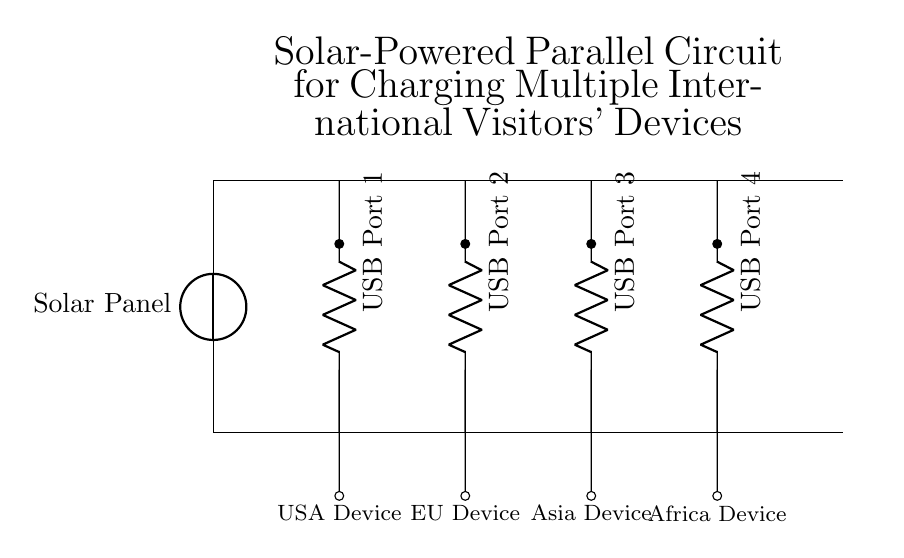What components are used in this circuit? The circuit diagram shows a solar panel and four USB ports. Each USB port connects to different devices.
Answer: solar panel, 4 USB ports How many devices can be charged simultaneously? The diagram illustrates four USB ports, each connected to a different device, allowing all four to be charged at once.
Answer: four devices What is the purpose of the solar panel in this circuit? The solar panel serves as the main power source, providing renewable energy to charge the devices connected via the USB ports.
Answer: power source Are the USB ports connected in series or parallel? The connections show that the USB ports have separate paths, indicating that they are connected in parallel, allowing equal voltage to each port.
Answer: parallel What types of devices are represented in the circuit? The circuit includes devices from different regions, identified by their names at the bottom of each port: USA Device, EU Device, Asia Device, and Africa Device.
Answer: USA, EU, Asia, Africa devices What advantage does using a parallel circuit provide in this design? A parallel circuit allows each USB port to receive the same voltage and operate independently, so if one device is removed or not drawing power, the others continue charging.
Answer: independent operation 